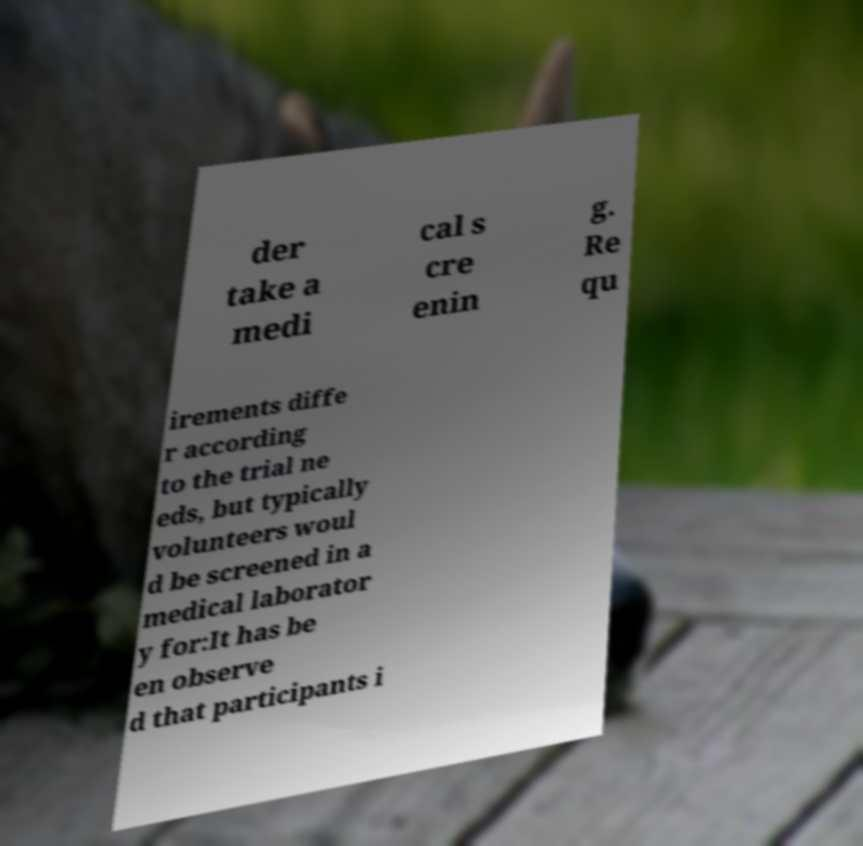There's text embedded in this image that I need extracted. Can you transcribe it verbatim? der take a medi cal s cre enin g. Re qu irements diffe r according to the trial ne eds, but typically volunteers woul d be screened in a medical laborator y for:It has be en observe d that participants i 